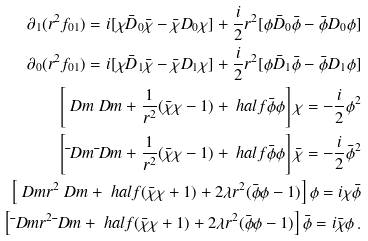Convert formula to latex. <formula><loc_0><loc_0><loc_500><loc_500>\partial _ { 1 } ( r ^ { 2 } f _ { 0 1 } ) = i [ \chi \bar { D } _ { 0 } \bar { \chi } - \bar { \chi } D _ { 0 } \chi ] + \frac { i } { 2 } r ^ { 2 } [ \phi \bar { D } _ { 0 } \bar { \phi } - \bar { \phi } D _ { 0 } \phi ] \\ \partial _ { 0 } ( r ^ { 2 } f _ { 0 1 } ) = i [ \chi \bar { D } _ { 1 } \bar { \chi } - \bar { \chi } D _ { 1 } \chi ] + \frac { i } { 2 } r ^ { 2 } [ \phi \bar { D } _ { 1 } \bar { \phi } - \bar { \phi } D _ { 1 } \phi ] \\ \left [ \ D m \ D m + \frac { 1 } { r ^ { 2 } } ( \bar { \chi } \chi - 1 ) + \ h a l f \bar { \phi } \phi \right ] \chi = - \frac { i } { 2 } \phi ^ { 2 } \\ \left [ \bar { \ } D m \bar { \ } D m + \frac { 1 } { r ^ { 2 } } ( \bar { \chi } \chi - 1 ) + \ h a l f \bar { \phi } \phi \right ] \bar { \chi } = - \frac { i } { 2 } \bar { \phi } ^ { 2 } \\ \left [ \ D m r ^ { 2 } \ D m + \ h a l f ( \bar { \chi } \chi + 1 ) + 2 \lambda r ^ { 2 } ( \bar { \phi } \phi - 1 ) \right ] \phi = i \chi \bar { \phi } \\ \left [ \bar { \ } D m r ^ { 2 } \bar { \ } D m + \ h a l f ( \bar { \chi } \chi + 1 ) + 2 \lambda r ^ { 2 } ( \bar { \phi } \phi - 1 ) \right ] \bar { \phi } = i \bar { \chi } \phi \, .</formula> 